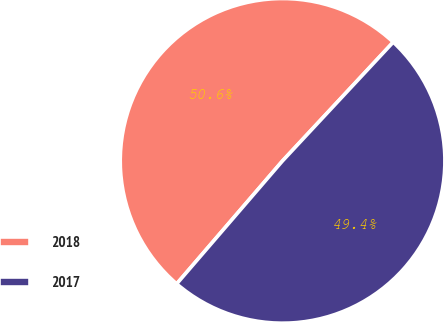<chart> <loc_0><loc_0><loc_500><loc_500><pie_chart><fcel>2018<fcel>2017<nl><fcel>50.63%<fcel>49.37%<nl></chart> 